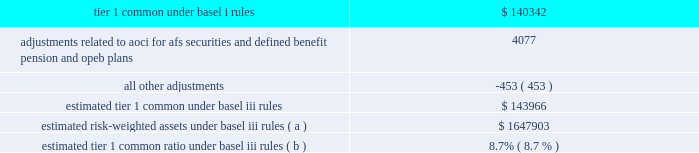Jpmorgan chase & co./2012 annual report 119 implementing further revisions to the capital accord in the u.s .
( such further revisions are commonly referred to as 201cbasel iii 201d ) .
Basel iii revised basel ii by , among other things , narrowing the definition of capital , and increasing capital requirements for specific exposures .
Basel iii also includes higher capital ratio requirements and provides that the tier 1 common capital requirement will be increased to 7% ( 7 % ) , comprised of a minimum ratio of 4.5% ( 4.5 % ) plus a 2.5% ( 2.5 % ) capital conservation buffer .
Implementation of the 7% ( 7 % ) tier 1 common capital requirement is required by january 1 , in addition , global systemically important banks ( 201cgsibs 201d ) will be required to maintain tier 1 common requirements above the 7% ( 7 % ) minimum in amounts ranging from an additional 1% ( 1 % ) to an additional 2.5% ( 2.5 % ) .
In november 2012 , the financial stability board ( 201cfsb 201d ) indicated that it would require the firm , as well as three other banks , to hold the additional 2.5% ( 2.5 % ) of tier 1 common ; the requirement will be phased in beginning in 2016 .
The basel committee also stated it intended to require certain gsibs to hold an additional 1% ( 1 % ) of tier 1 common under certain circumstances , to act as a disincentive for the gsib from taking actions that would further increase its systemic importance .
Currently , no gsib ( including the firm ) is required to hold this additional 1% ( 1 % ) of tier 1 common .
In addition , pursuant to the requirements of the dodd-frank act , u.s .
Federal banking agencies have proposed certain permanent basel i floors under basel ii and basel iii capital calculations .
The table presents a comparison of the firm 2019s tier 1 common under basel i rules to its estimated tier 1 common under basel iii rules , along with the firm 2019s estimated risk-weighted assets .
Tier 1 common under basel iii includes additional adjustments and deductions not included in basel i tier 1 common , such as the inclusion of aoci related to afs securities and defined benefit pension and other postretirement employee benefit ( 201copeb 201d ) plans .
The firm estimates that its tier 1 common ratio under basel iii rules would be 8.7% ( 8.7 % ) as of december 31 , 2012 .
The tier 1 common ratio under both basel i and basel iii are non- gaap financial measures .
However , such measures are used by bank regulators , investors and analysts as a key measure to assess the firm 2019s capital position and to compare the firm 2019s capital to that of other financial services companies .
December 31 , 2012 ( in millions , except ratios ) .
Estimated risk-weighted assets under basel iii rules ( a ) $ 1647903 estimated tier 1 common ratio under basel iii rules ( b ) 8.7% ( 8.7 % ) ( a ) key differences in the calculation of risk-weighted assets between basel i and basel iii include : ( 1 ) basel iii credit risk rwa is based on risk-sensitive approaches which largely rely on the use of internal credit models and parameters , whereas basel i rwa is based on fixed supervisory risk weightings which vary only by counterparty type and asset class ; ( 2 ) basel iii market risk rwa reflects the new capital requirements related to trading assets and securitizations , which include incremental capital requirements for stress var , correlation trading , and re-securitization positions ; and ( 3 ) basel iii includes rwa for operational risk , whereas basel i does not .
The actual impact on the firm 2019s capital ratios upon implementation could differ depending on final implementation guidance from the regulators , as well as regulatory approval of certain of the firm 2019s internal risk models .
( b ) the tier 1 common ratio is tier 1 common divided by rwa .
The firm 2019s estimate of its tier 1 common ratio under basel iii reflects its current understanding of the basel iii rules based on information currently published by the basel committee and u.s .
Federal banking agencies and on the application of such rules to its businesses as currently conducted ; it excludes the impact of any changes the firm may make in the future to its businesses as a result of implementing the basel iii rules , possible enhancements to certain market risk models , and any further implementation guidance from the regulators .
The basel iii capital requirements are subject to prolonged transition periods .
The transition period for banks to meet the tier 1 common requirement under basel iii was originally scheduled to begin in 2013 , with full implementation on january 1 , 2019 .
In november 2012 , the u.s .
Federal banking agencies announced a delay in the implementation dates for the basel iii capital requirements .
The additional capital requirements for gsibs will be phased in starting january 1 , 2016 , with full implementation on january 1 , 2019 .
Management 2019s current objective is for the firm to reach , by the end of 2013 , an estimated basel iii tier i common ratio of 9.5% ( 9.5 % ) .
Additional information regarding the firm 2019s capital ratios and the federal regulatory capital standards to which it is subject is presented in supervision and regulation on pages 1 20138 of the 2012 form 10-k , and note 28 on pages 306 2013 308 of this annual report .
Broker-dealer regulatory capital jpmorgan chase 2019s principal u.s .
Broker-dealer subsidiaries are j.p .
Morgan securities llc ( 201cjpmorgan securities 201d ) and j.p .
Morgan clearing corp .
( 201cjpmorgan clearing 201d ) .
Jpmorgan clearing is a subsidiary of jpmorgan securities and provides clearing and settlement services .
Jpmorgan securities and jpmorgan clearing are each subject to rule 15c3-1 under the securities exchange act of 1934 ( the 201cnet capital rule 201d ) .
Jpmorgan securities and jpmorgan clearing are also each registered as futures commission merchants and subject to rule 1.17 of the commodity futures trading commission ( 201ccftc 201d ) .
Jpmorgan securities and jpmorgan clearing have elected to compute their minimum net capital requirements in accordance with the 201calternative net capital requirements 201d of the net capital rule .
At december 31 , 2012 , jpmorgan securities 2019 net capital , as defined by the net capital rule , was $ 13.5 billion , exceeding the minimum requirement by .
Does the current estimated basel iii tier 1 ratio exceed the requirement under basel iii rules as a gsib , once the requirements a re fully phased in? 
Computations: (8.7% > 9.5%)
Answer: no. 